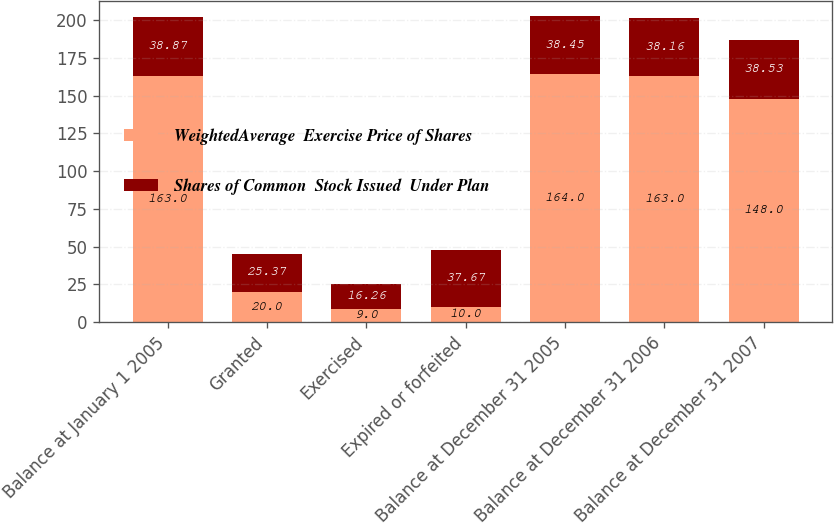<chart> <loc_0><loc_0><loc_500><loc_500><stacked_bar_chart><ecel><fcel>Balance at January 1 2005<fcel>Granted<fcel>Exercised<fcel>Expired or forfeited<fcel>Balance at December 31 2005<fcel>Balance at December 31 2006<fcel>Balance at December 31 2007<nl><fcel>WeightedAverage  Exercise Price of Shares<fcel>163<fcel>20<fcel>9<fcel>10<fcel>164<fcel>163<fcel>148<nl><fcel>Shares of Common  Stock Issued  Under Plan<fcel>38.87<fcel>25.37<fcel>16.26<fcel>37.67<fcel>38.45<fcel>38.16<fcel>38.53<nl></chart> 